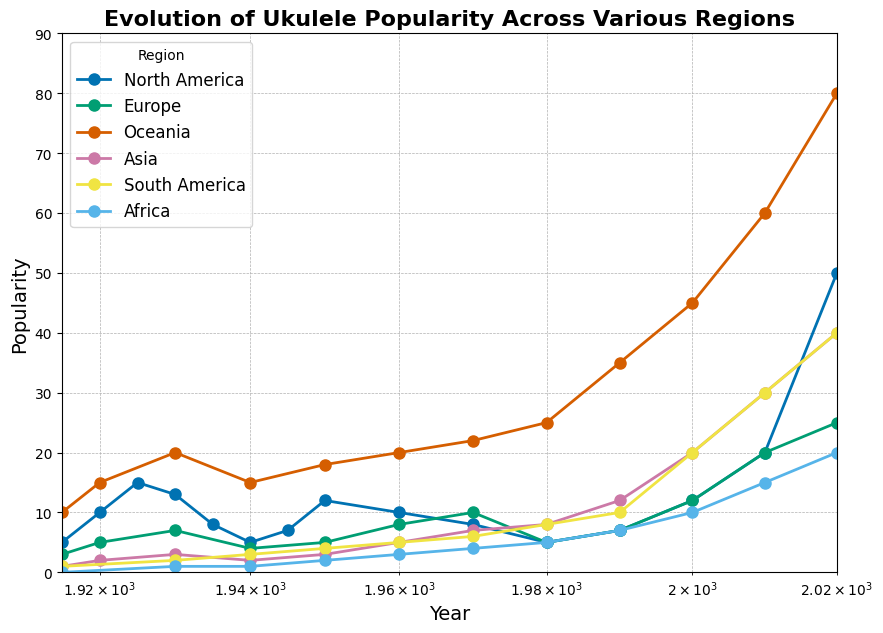What region showed the highest ukulele popularity in 2020? By examining the figure, we can see that the line representing Oceania has the highest point in 2020, reaching up to a popularity value of 80. This indicates that Oceania showed the highest ukulele popularity in 2020.
Answer: Oceania Which region experienced a decline in popularity from 1915 to 1940? By observing the trends in the figure, North America is the region that experienced a decline in popularity from 1915 (5) to 1940 (5). Even though there were fluctuations, the popularity in 1940 was the same as in 1915, indicating a net decline over the time period.
Answer: North America Between Europe and Asia, which region had higher ukulele popularity in 2000, and by how much? By looking at the plot, in 2000, Europe had a popularity of 12, while Asia had a popularity of 20. So, Asia had a higher popularity by 20 - 12 = 8.
Answer: Asia by 8 What was the overall trend in ukulele popularity in North America from 1980 to 2020? The figure shows that the popularity in North America decreased from 1980 (5) to 2000 (12), but then significantly increased from 2000 (12) to 2020 (50). Therefore, the overall trend in North America from 1980 to 2020 is an increasing trend.
Answer: Increasing Which region experienced the most consistent growth in popularity from 1915 to 2020? By examining all the lines in the figure, Oceania shows a consistent upward trend with growth at each interval from 1915 (10) to 2020 (80). This demonstrates the most consistent growth among all the regions.
Answer: Oceania Compare the popularity change in South America and Africa between 1990 and 2020. From the figure, in 1990, South America's popularity was 10 and increased to 40 by 2020. Africa's popularity was 7 in 1990 and increased to 20 by 2020. The increase for South America is 40 - 10 = 30, whereas for Africa it is 20 - 7 = 13. Therefore, South America's popularity change was greater.
Answer: South America by 17 What was the difference in ukulele popularity between 1930 and 1980 in Oceania? In 1930, Oceania's popularity was 20 and in 1980, it was 25. The difference is 25 - 20 = 5.
Answer: 5 Which region had the sharpest increase in popularity between 2010 and 2020? By inspecting the trends between 2010 and 2020, North America had the sharpest increase, from 20 to 50, making it an increase of 30, which is the highest among all regions.
Answer: North America How did the popularity of ukuleles in Asia change from 1950 to 2020? From the plot, Asia's popularity in 1950 was 3 and grew steadily to 40 by 2020, illustrating a significant increase over this period.
Answer: Increased 